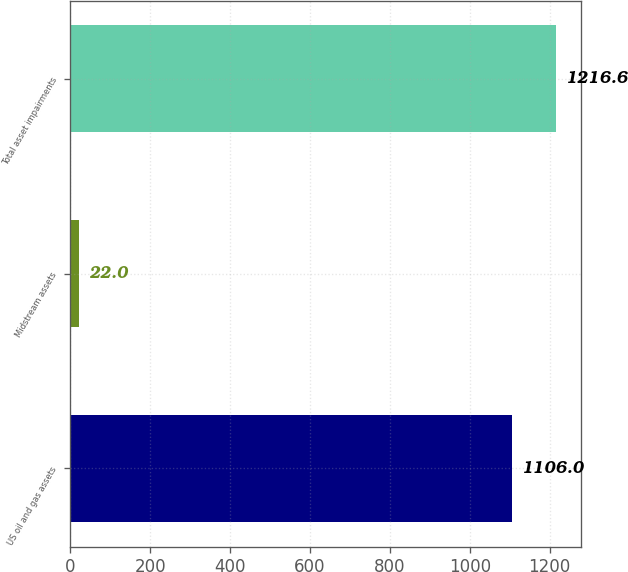Convert chart to OTSL. <chart><loc_0><loc_0><loc_500><loc_500><bar_chart><fcel>US oil and gas assets<fcel>Midstream assets<fcel>Total asset impairments<nl><fcel>1106<fcel>22<fcel>1216.6<nl></chart> 